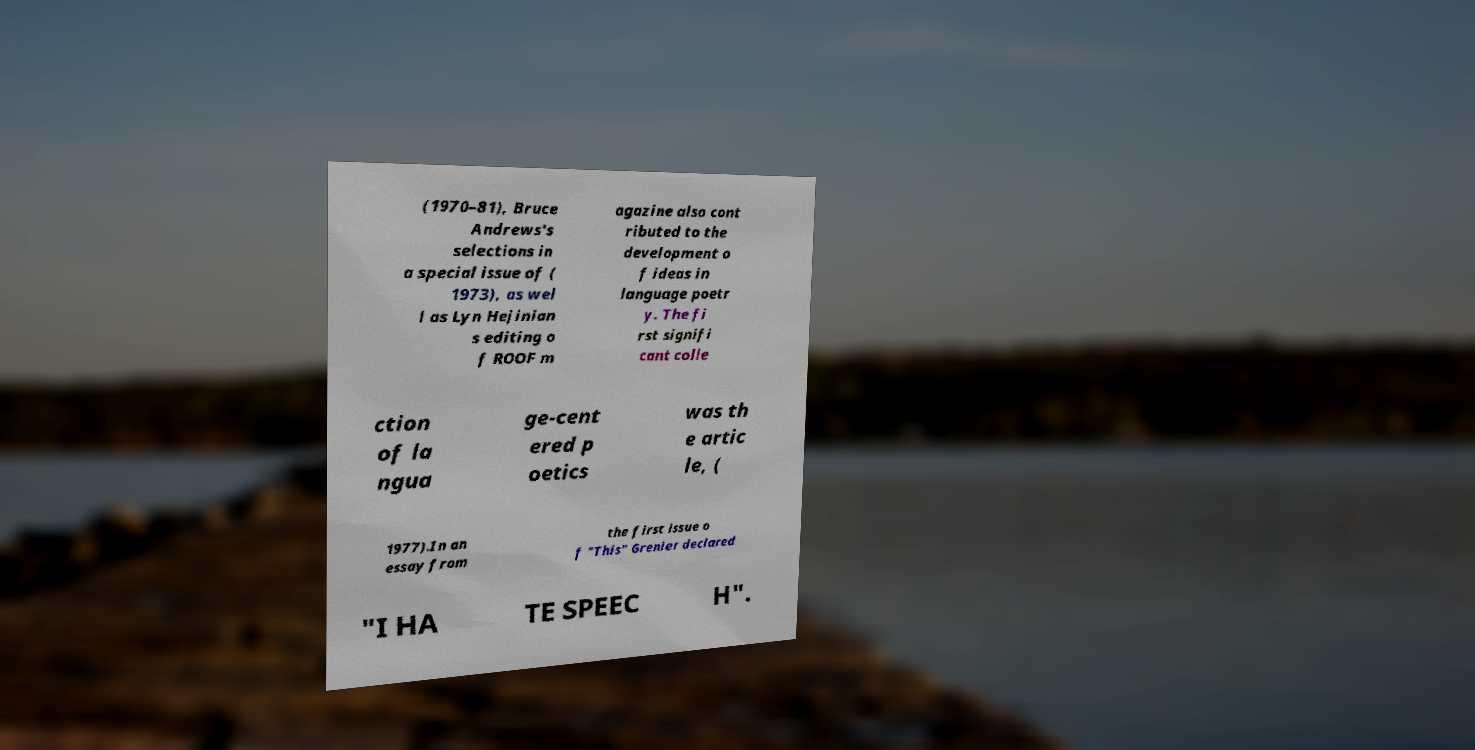Could you assist in decoding the text presented in this image and type it out clearly? (1970–81), Bruce Andrews's selections in a special issue of ( 1973), as wel l as Lyn Hejinian s editing o f ROOF m agazine also cont ributed to the development o f ideas in language poetr y. The fi rst signifi cant colle ction of la ngua ge-cent ered p oetics was th e artic le, ( 1977).In an essay from the first issue o f "This" Grenier declared "I HA TE SPEEC H". 